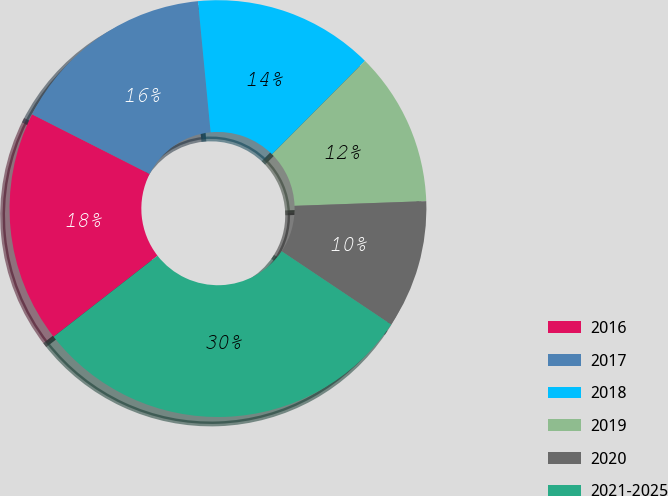Convert chart to OTSL. <chart><loc_0><loc_0><loc_500><loc_500><pie_chart><fcel>2016<fcel>2017<fcel>2018<fcel>2019<fcel>2020<fcel>2021-2025<nl><fcel>18.01%<fcel>16.0%<fcel>13.99%<fcel>11.97%<fcel>9.96%<fcel>30.07%<nl></chart> 